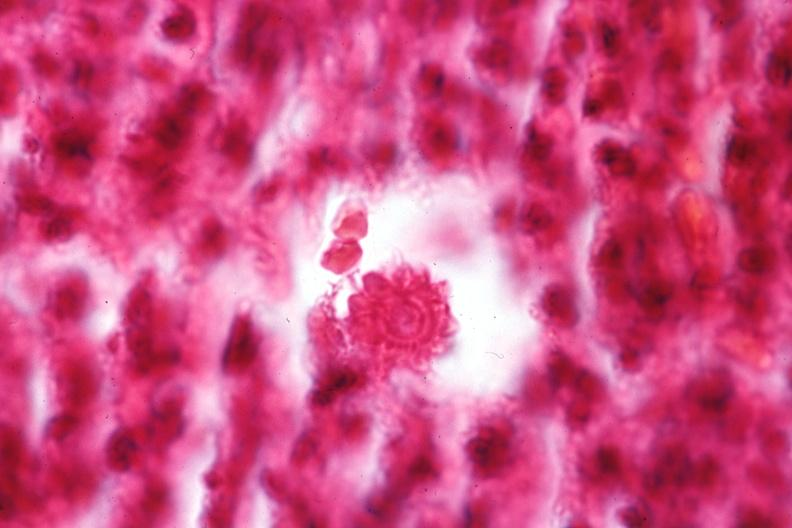s sporotrichosis present?
Answer the question using a single word or phrase. Yes 